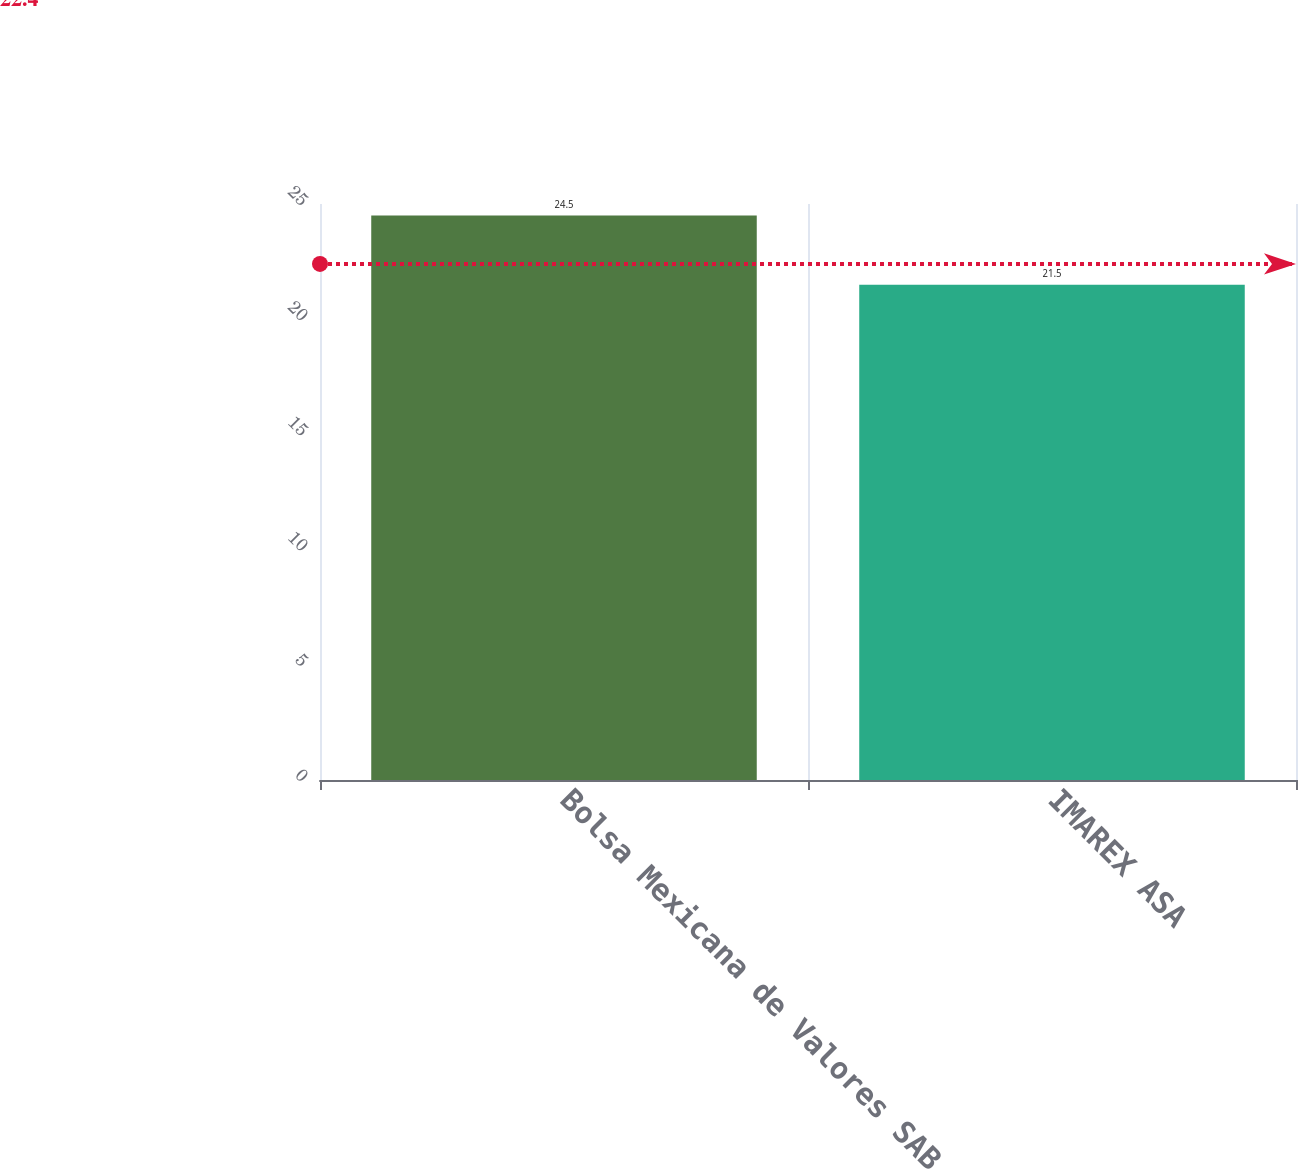Convert chart to OTSL. <chart><loc_0><loc_0><loc_500><loc_500><bar_chart><fcel>Bolsa Mexicana de Valores SAB<fcel>IMAREX ASA<nl><fcel>24.5<fcel>21.5<nl></chart> 